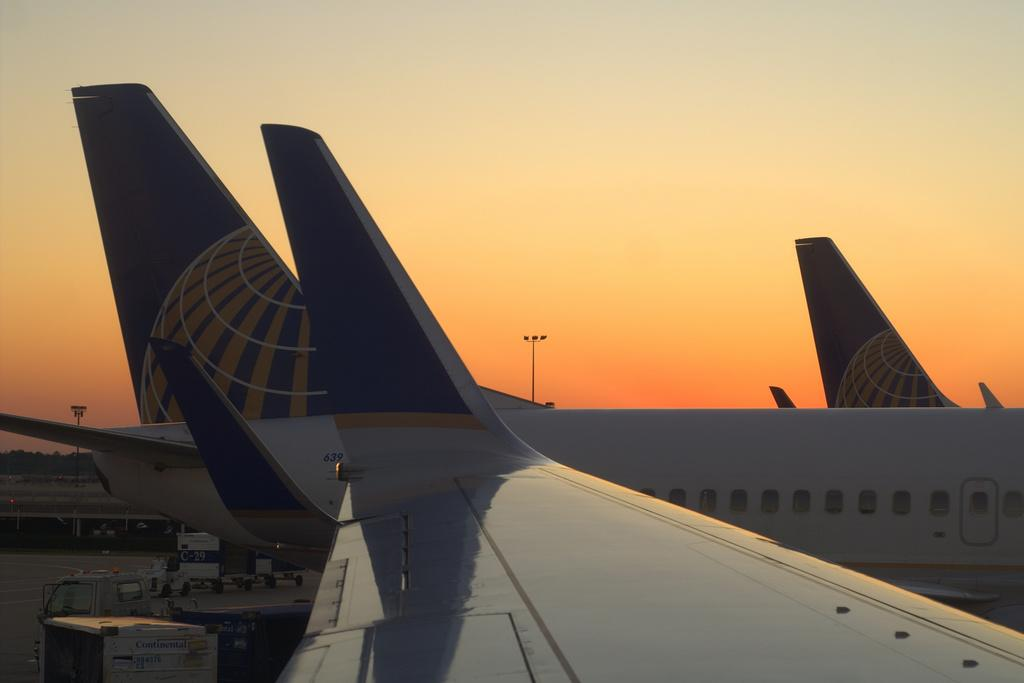What is the main subject of the image? The main subject of the image is aeroplanes. Can you describe any other objects or vehicles in the image? Yes, there are vehicles at the left side bottom of the image. What can be seen in the background of the image? The sky is visible in the background of the image. What type of hill can be seen in the background of the image? There is no hill present in the image; only the sky is visible in the background. 